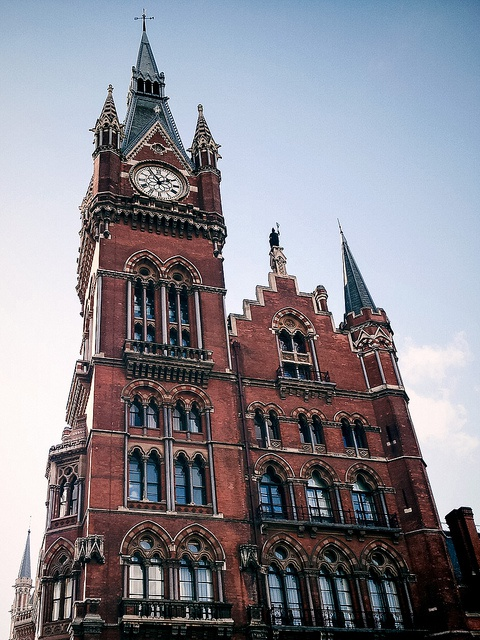Describe the objects in this image and their specific colors. I can see a clock in darkgray, lightgray, gray, and black tones in this image. 